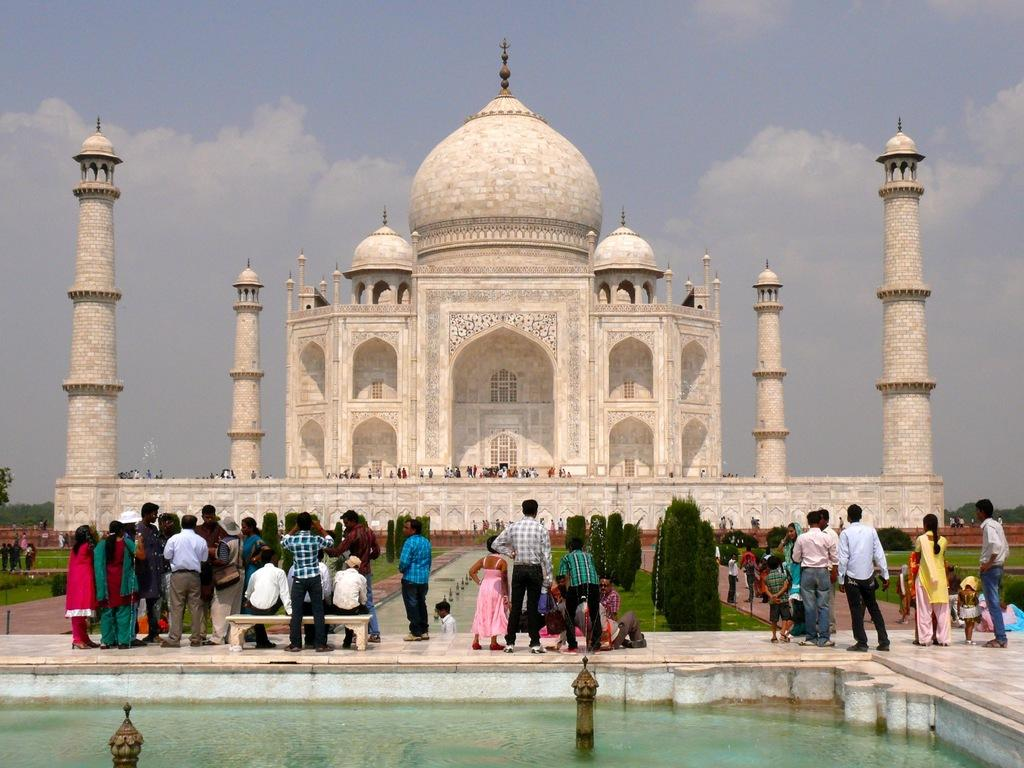What famous landmark is visible in the image? The Taj Mahal is visible in the image. Are there any people present in the image? Yes, there are people around the Taj Mahal and people sitting on a bench in the image. What type of vegetation can be seen in the image? There are trees in the image. What is the water feature in the image? There is a fountain in the image, and it has water. What is visible in the sky in the image? The sky is visible in the image. How many heads are visible in the image? There are no heads visible in the image. 